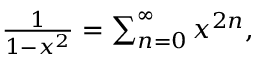Convert formula to latex. <formula><loc_0><loc_0><loc_500><loc_500>\begin{array} { r } { \frac { 1 } { 1 - x ^ { 2 } } = \sum _ { n = 0 } ^ { \infty } x ^ { 2 n } , } \end{array}</formula> 